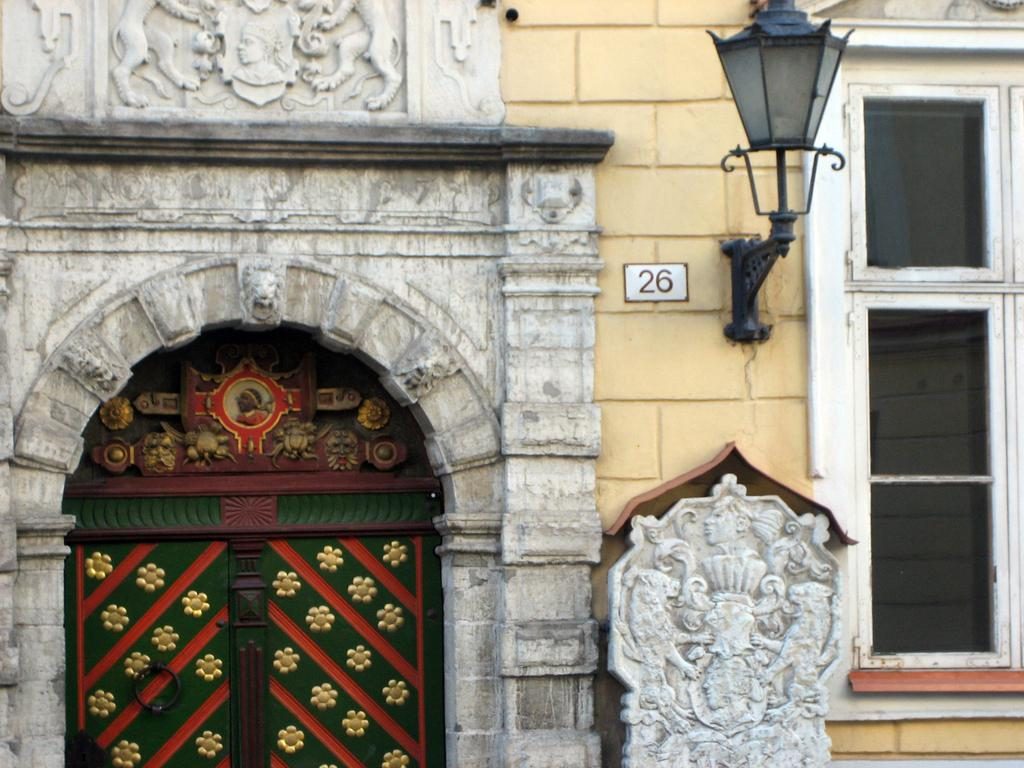What architectural feature can be seen in the image? There is a window and a door in the image. What type of lighting is present in the image? There is a lamp in the image. What decorative elements are on the wall in the image? There are sculptures on the wall in the image. What type of food is being prepared in the image? There is no food or indication of food preparation in the image. How many bushes are visible in the image? There are no bushes present in the image. 